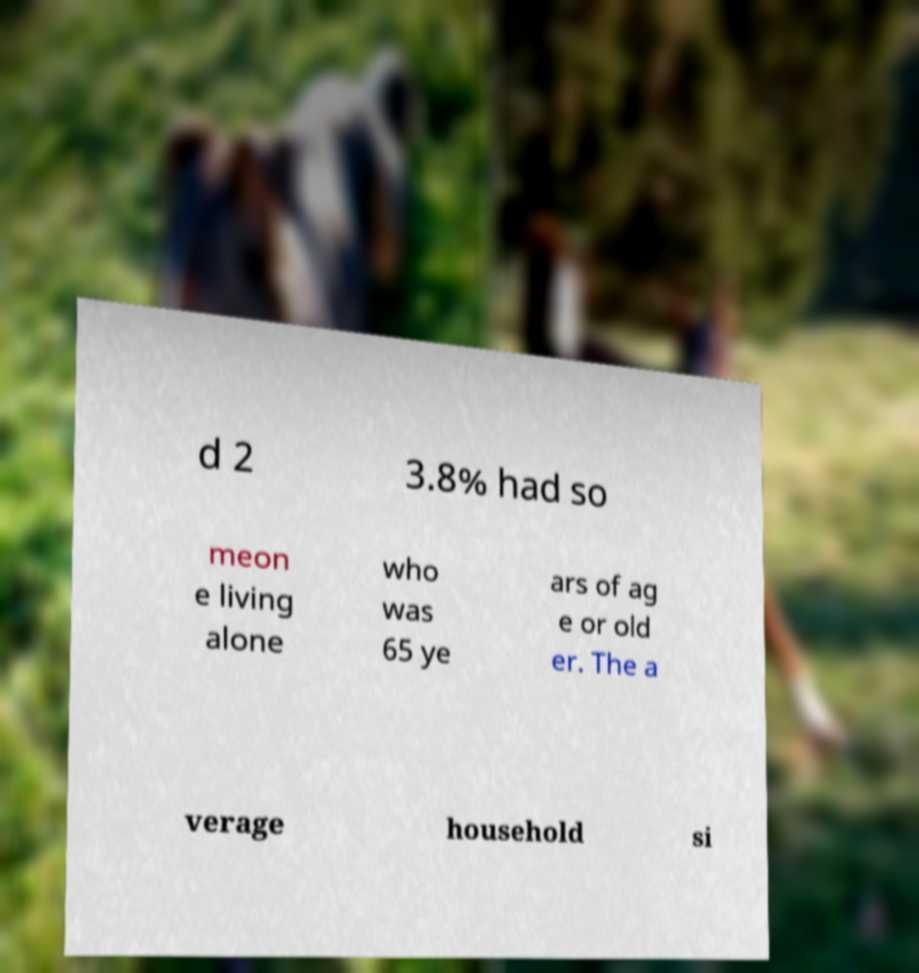I need the written content from this picture converted into text. Can you do that? d 2 3.8% had so meon e living alone who was 65 ye ars of ag e or old er. The a verage household si 